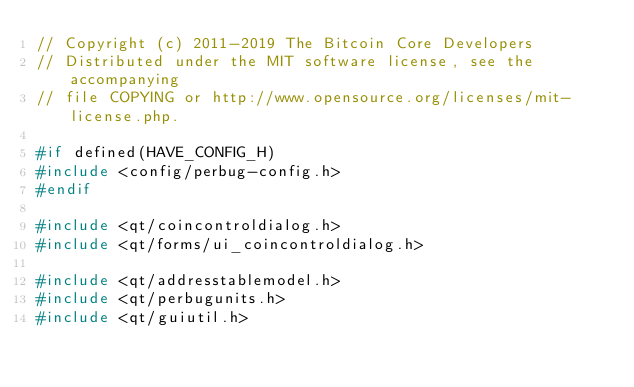<code> <loc_0><loc_0><loc_500><loc_500><_C++_>// Copyright (c) 2011-2019 The Bitcoin Core Developers
// Distributed under the MIT software license, see the accompanying
// file COPYING or http://www.opensource.org/licenses/mit-license.php.

#if defined(HAVE_CONFIG_H)
#include <config/perbug-config.h>
#endif

#include <qt/coincontroldialog.h>
#include <qt/forms/ui_coincontroldialog.h>

#include <qt/addresstablemodel.h>
#include <qt/perbugunits.h>
#include <qt/guiutil.h></code> 